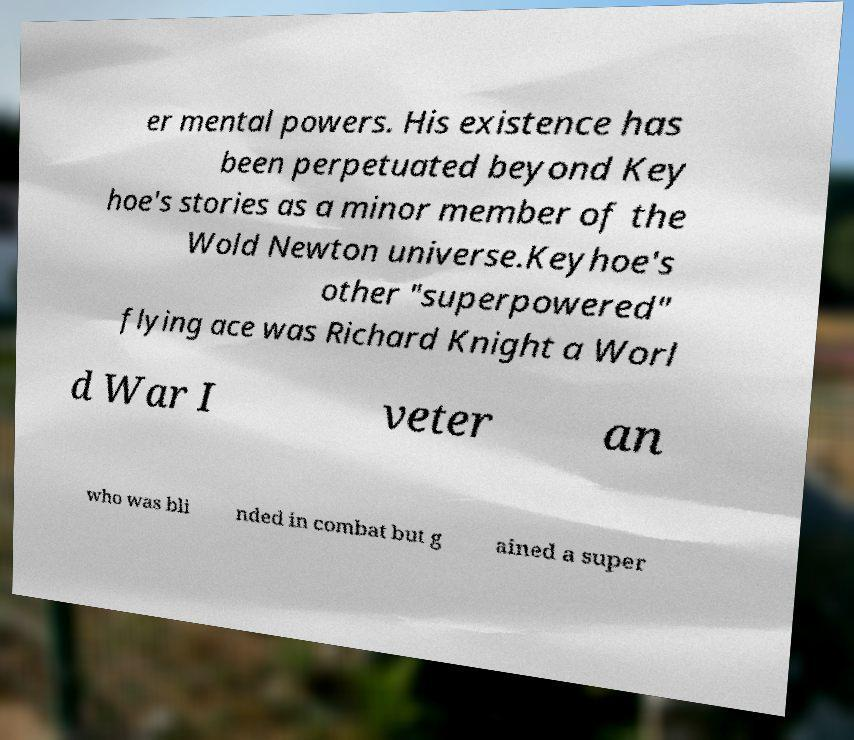Please read and relay the text visible in this image. What does it say? er mental powers. His existence has been perpetuated beyond Key hoe's stories as a minor member of the Wold Newton universe.Keyhoe's other "superpowered" flying ace was Richard Knight a Worl d War I veter an who was bli nded in combat but g ained a super 